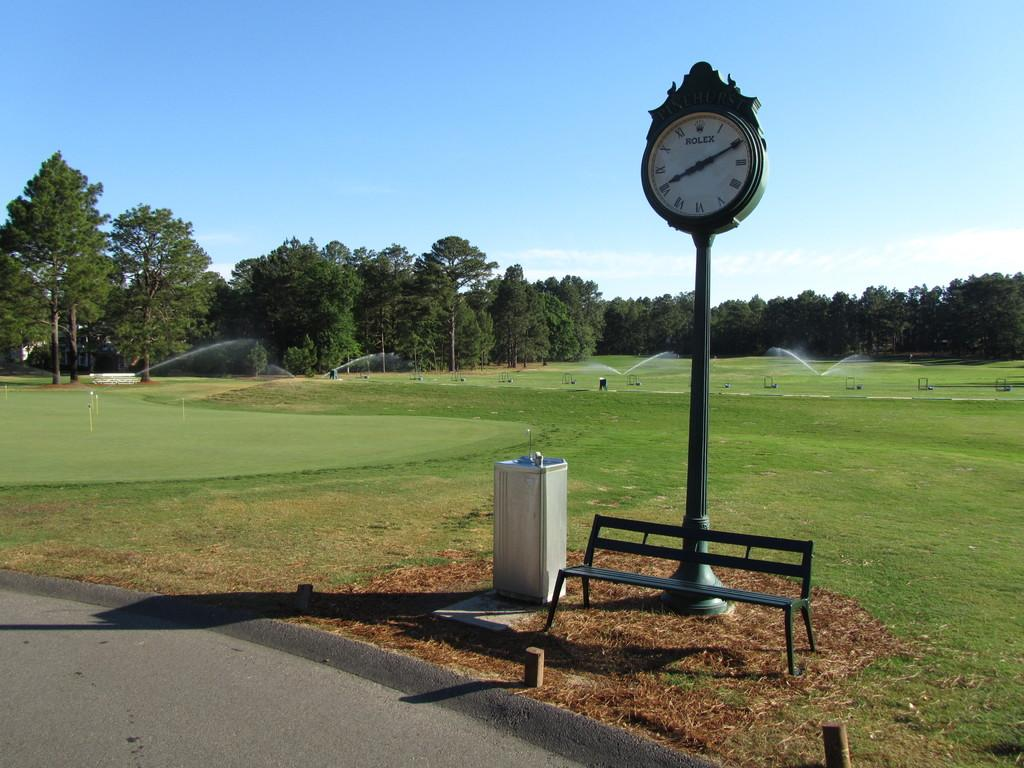<image>
Provide a brief description of the given image. A Rolex clock is outside next to a garbage can and behind a bench. 